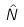<formula> <loc_0><loc_0><loc_500><loc_500>\hat { N }</formula> 